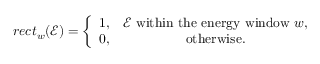<formula> <loc_0><loc_0><loc_500><loc_500>r e c t _ { w } ( \mathcal { E } ) = \left \{ \begin{array} { c c } { 1 , } & { { \mathcal { E } w i t h i n t h e e n e r g y w i n d o w w , } } \\ { 0 , } & { { o t h e r w i s e } . } \end{array}</formula> 